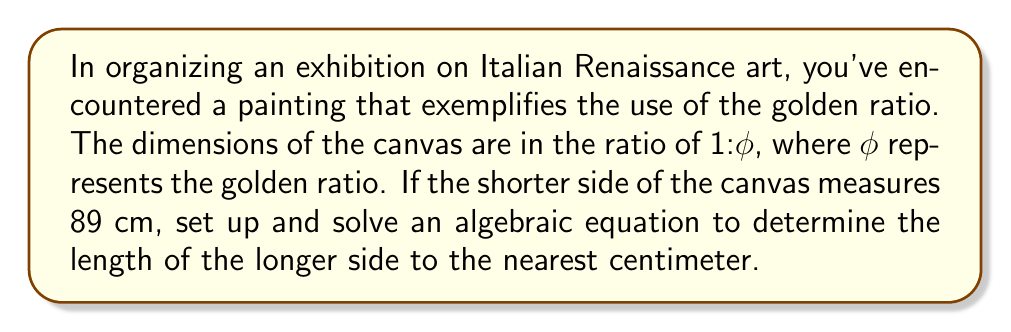Show me your answer to this math problem. To solve this problem, we'll use the definition of the golden ratio and set up an algebraic equation.

1) The golden ratio, φ, is defined by the equation:

   $$ \phi = \frac{a+b}{a} = \frac{a}{b} $$

   where $a$ is the longer side and $b$ is the shorter side.

2) We're given that $b = 89$ cm. Let's call the longer side $x$ cm.

3) Using the definition of the golden ratio, we can set up the equation:

   $$ \phi = \frac{x}{89} $$

4) The value of φ is the positive solution to the quadratic equation $x^2 - x - 1 = 0$. This value is:

   $$ \phi = \frac{1 + \sqrt{5}}{2} \approx 1.618033989 $$

5) Substituting this into our equation:

   $$ 1.618033989 = \frac{x}{89} $$

6) Solving for $x$:

   $$ x = 89 * 1.618033989 = 144.00502502 $$

7) Rounding to the nearest centimeter:

   $$ x \approx 144 \text{ cm} $$
Answer: The length of the longer side of the canvas is approximately 144 cm. 